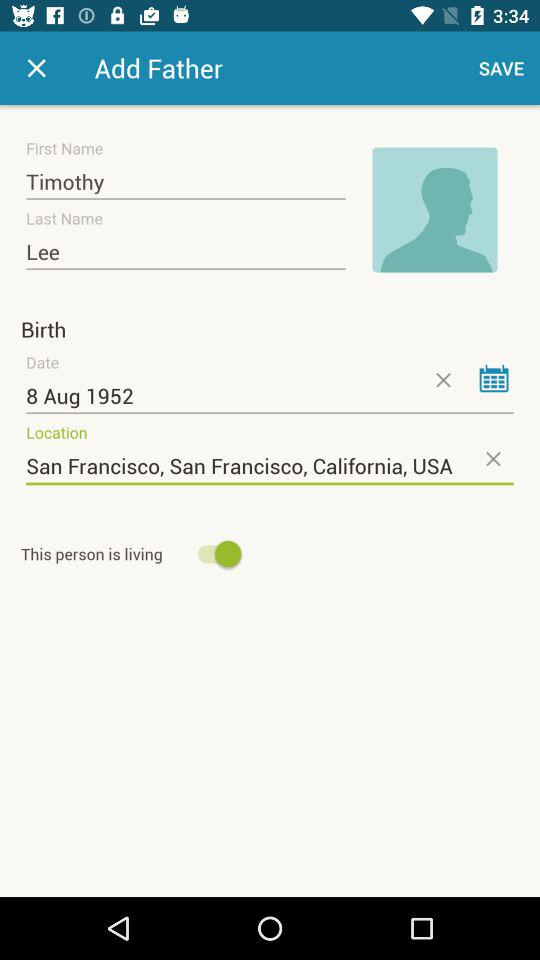What is the status of "This person is living"? The status of "This person is living" is on. 